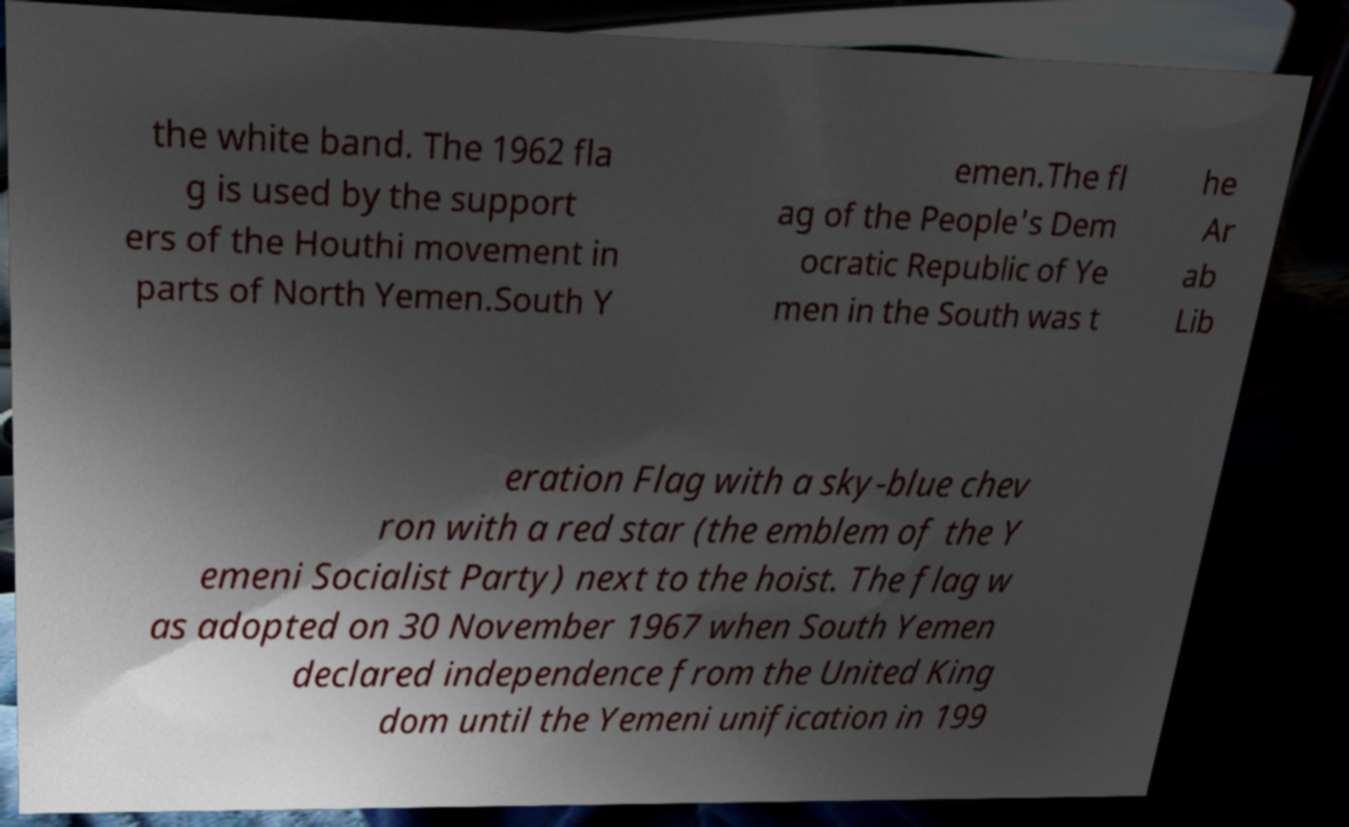Could you extract and type out the text from this image? the white band. The 1962 fla g is used by the support ers of the Houthi movement in parts of North Yemen.South Y emen.The fl ag of the People's Dem ocratic Republic of Ye men in the South was t he Ar ab Lib eration Flag with a sky-blue chev ron with a red star (the emblem of the Y emeni Socialist Party) next to the hoist. The flag w as adopted on 30 November 1967 when South Yemen declared independence from the United King dom until the Yemeni unification in 199 